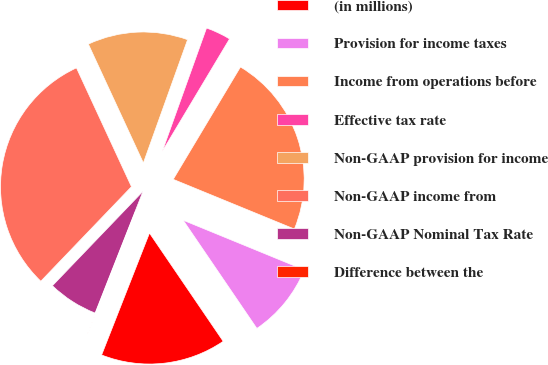<chart> <loc_0><loc_0><loc_500><loc_500><pie_chart><fcel>(in millions)<fcel>Provision for income taxes<fcel>Income from operations before<fcel>Effective tax rate<fcel>Non-GAAP provision for income<fcel>Non-GAAP income from<fcel>Non-GAAP Nominal Tax Rate<fcel>Difference between the<nl><fcel>15.47%<fcel>9.29%<fcel>22.61%<fcel>3.1%<fcel>12.38%<fcel>30.93%<fcel>6.2%<fcel>0.01%<nl></chart> 